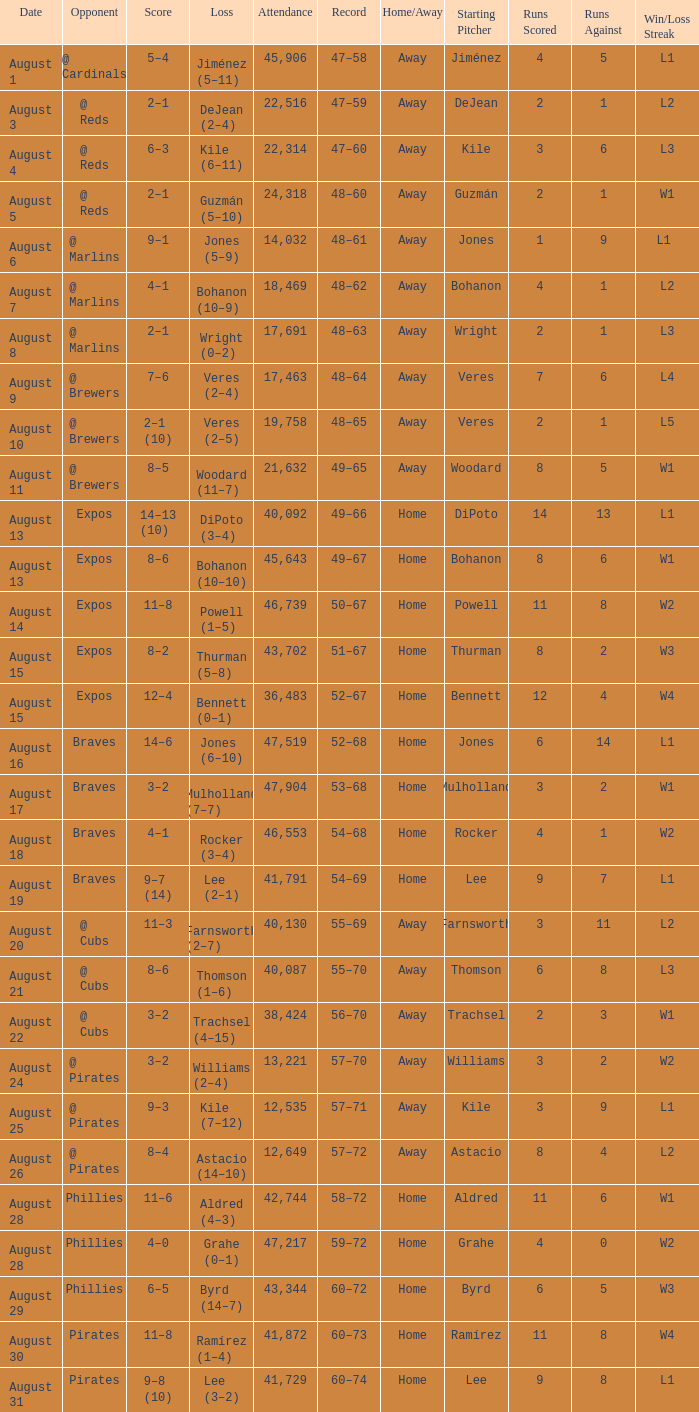What is the lowest attendance total on August 26? 12649.0. 